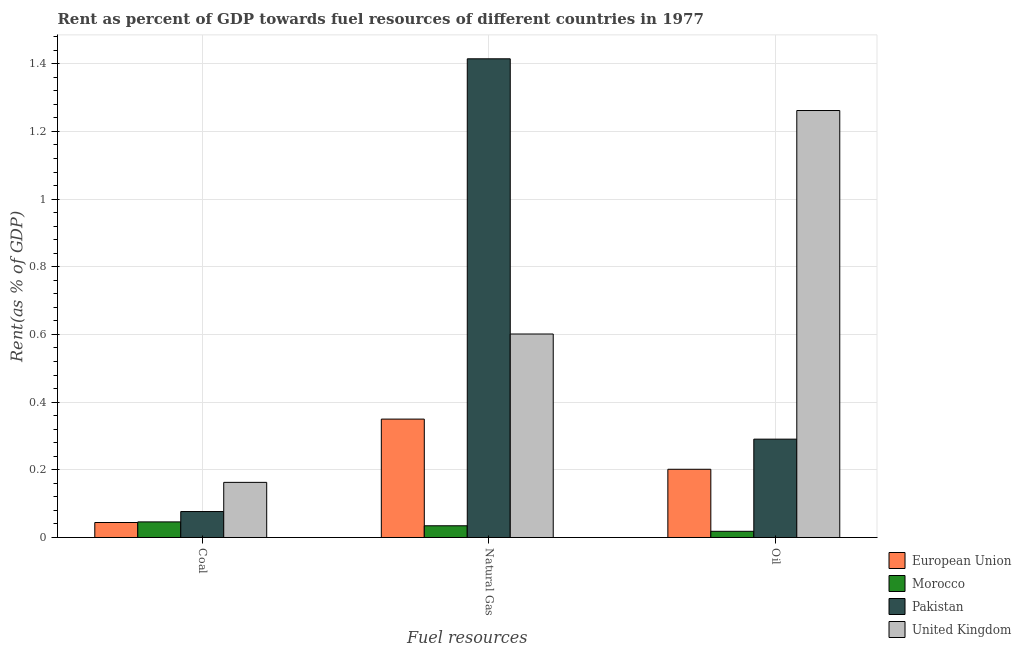How many different coloured bars are there?
Offer a terse response. 4. How many bars are there on the 3rd tick from the left?
Give a very brief answer. 4. What is the label of the 1st group of bars from the left?
Your answer should be compact. Coal. What is the rent towards coal in United Kingdom?
Give a very brief answer. 0.16. Across all countries, what is the maximum rent towards oil?
Offer a very short reply. 1.26. Across all countries, what is the minimum rent towards coal?
Your answer should be very brief. 0.04. In which country was the rent towards oil maximum?
Keep it short and to the point. United Kingdom. In which country was the rent towards coal minimum?
Provide a succinct answer. European Union. What is the total rent towards natural gas in the graph?
Provide a succinct answer. 2.4. What is the difference between the rent towards oil in Pakistan and that in United Kingdom?
Keep it short and to the point. -0.97. What is the difference between the rent towards oil in United Kingdom and the rent towards coal in Pakistan?
Your answer should be very brief. 1.18. What is the average rent towards natural gas per country?
Your answer should be compact. 0.6. What is the difference between the rent towards coal and rent towards oil in United Kingdom?
Give a very brief answer. -1.1. In how many countries, is the rent towards oil greater than 0.8400000000000001 %?
Ensure brevity in your answer.  1. What is the ratio of the rent towards oil in Morocco to that in European Union?
Make the answer very short. 0.09. Is the rent towards oil in United Kingdom less than that in Pakistan?
Your response must be concise. No. Is the difference between the rent towards natural gas in United Kingdom and Pakistan greater than the difference between the rent towards coal in United Kingdom and Pakistan?
Keep it short and to the point. No. What is the difference between the highest and the second highest rent towards oil?
Offer a very short reply. 0.97. What is the difference between the highest and the lowest rent towards oil?
Keep it short and to the point. 1.24. In how many countries, is the rent towards natural gas greater than the average rent towards natural gas taken over all countries?
Offer a very short reply. 2. What does the 2nd bar from the left in Natural Gas represents?
Your answer should be very brief. Morocco. What does the 4th bar from the right in Natural Gas represents?
Provide a succinct answer. European Union. Is it the case that in every country, the sum of the rent towards coal and rent towards natural gas is greater than the rent towards oil?
Offer a very short reply. No. How many bars are there?
Offer a terse response. 12. Are the values on the major ticks of Y-axis written in scientific E-notation?
Ensure brevity in your answer.  No. Where does the legend appear in the graph?
Your response must be concise. Bottom right. How many legend labels are there?
Make the answer very short. 4. How are the legend labels stacked?
Give a very brief answer. Vertical. What is the title of the graph?
Ensure brevity in your answer.  Rent as percent of GDP towards fuel resources of different countries in 1977. What is the label or title of the X-axis?
Offer a terse response. Fuel resources. What is the label or title of the Y-axis?
Provide a short and direct response. Rent(as % of GDP). What is the Rent(as % of GDP) of European Union in Coal?
Keep it short and to the point. 0.04. What is the Rent(as % of GDP) of Morocco in Coal?
Your response must be concise. 0.05. What is the Rent(as % of GDP) of Pakistan in Coal?
Ensure brevity in your answer.  0.08. What is the Rent(as % of GDP) of United Kingdom in Coal?
Offer a terse response. 0.16. What is the Rent(as % of GDP) of European Union in Natural Gas?
Provide a short and direct response. 0.35. What is the Rent(as % of GDP) of Morocco in Natural Gas?
Your answer should be compact. 0.03. What is the Rent(as % of GDP) of Pakistan in Natural Gas?
Ensure brevity in your answer.  1.41. What is the Rent(as % of GDP) of United Kingdom in Natural Gas?
Keep it short and to the point. 0.6. What is the Rent(as % of GDP) in European Union in Oil?
Provide a short and direct response. 0.2. What is the Rent(as % of GDP) in Morocco in Oil?
Provide a short and direct response. 0.02. What is the Rent(as % of GDP) in Pakistan in Oil?
Your response must be concise. 0.29. What is the Rent(as % of GDP) of United Kingdom in Oil?
Make the answer very short. 1.26. Across all Fuel resources, what is the maximum Rent(as % of GDP) of European Union?
Offer a terse response. 0.35. Across all Fuel resources, what is the maximum Rent(as % of GDP) in Morocco?
Keep it short and to the point. 0.05. Across all Fuel resources, what is the maximum Rent(as % of GDP) in Pakistan?
Provide a short and direct response. 1.41. Across all Fuel resources, what is the maximum Rent(as % of GDP) of United Kingdom?
Offer a terse response. 1.26. Across all Fuel resources, what is the minimum Rent(as % of GDP) of European Union?
Make the answer very short. 0.04. Across all Fuel resources, what is the minimum Rent(as % of GDP) in Morocco?
Offer a very short reply. 0.02. Across all Fuel resources, what is the minimum Rent(as % of GDP) of Pakistan?
Give a very brief answer. 0.08. Across all Fuel resources, what is the minimum Rent(as % of GDP) in United Kingdom?
Your response must be concise. 0.16. What is the total Rent(as % of GDP) in European Union in the graph?
Give a very brief answer. 0.6. What is the total Rent(as % of GDP) of Morocco in the graph?
Your response must be concise. 0.1. What is the total Rent(as % of GDP) in Pakistan in the graph?
Give a very brief answer. 1.78. What is the total Rent(as % of GDP) of United Kingdom in the graph?
Provide a short and direct response. 2.03. What is the difference between the Rent(as % of GDP) of European Union in Coal and that in Natural Gas?
Your answer should be very brief. -0.31. What is the difference between the Rent(as % of GDP) in Morocco in Coal and that in Natural Gas?
Ensure brevity in your answer.  0.01. What is the difference between the Rent(as % of GDP) in Pakistan in Coal and that in Natural Gas?
Provide a short and direct response. -1.34. What is the difference between the Rent(as % of GDP) of United Kingdom in Coal and that in Natural Gas?
Ensure brevity in your answer.  -0.44. What is the difference between the Rent(as % of GDP) of European Union in Coal and that in Oil?
Offer a very short reply. -0.16. What is the difference between the Rent(as % of GDP) in Morocco in Coal and that in Oil?
Keep it short and to the point. 0.03. What is the difference between the Rent(as % of GDP) in Pakistan in Coal and that in Oil?
Your answer should be compact. -0.21. What is the difference between the Rent(as % of GDP) of United Kingdom in Coal and that in Oil?
Offer a terse response. -1.1. What is the difference between the Rent(as % of GDP) of European Union in Natural Gas and that in Oil?
Give a very brief answer. 0.15. What is the difference between the Rent(as % of GDP) in Morocco in Natural Gas and that in Oil?
Provide a succinct answer. 0.02. What is the difference between the Rent(as % of GDP) of Pakistan in Natural Gas and that in Oil?
Provide a short and direct response. 1.12. What is the difference between the Rent(as % of GDP) of United Kingdom in Natural Gas and that in Oil?
Keep it short and to the point. -0.66. What is the difference between the Rent(as % of GDP) in European Union in Coal and the Rent(as % of GDP) in Morocco in Natural Gas?
Ensure brevity in your answer.  0.01. What is the difference between the Rent(as % of GDP) of European Union in Coal and the Rent(as % of GDP) of Pakistan in Natural Gas?
Your answer should be very brief. -1.37. What is the difference between the Rent(as % of GDP) in European Union in Coal and the Rent(as % of GDP) in United Kingdom in Natural Gas?
Offer a terse response. -0.56. What is the difference between the Rent(as % of GDP) of Morocco in Coal and the Rent(as % of GDP) of Pakistan in Natural Gas?
Make the answer very short. -1.37. What is the difference between the Rent(as % of GDP) in Morocco in Coal and the Rent(as % of GDP) in United Kingdom in Natural Gas?
Your answer should be very brief. -0.56. What is the difference between the Rent(as % of GDP) of Pakistan in Coal and the Rent(as % of GDP) of United Kingdom in Natural Gas?
Provide a succinct answer. -0.52. What is the difference between the Rent(as % of GDP) of European Union in Coal and the Rent(as % of GDP) of Morocco in Oil?
Give a very brief answer. 0.03. What is the difference between the Rent(as % of GDP) in European Union in Coal and the Rent(as % of GDP) in Pakistan in Oil?
Your answer should be very brief. -0.25. What is the difference between the Rent(as % of GDP) of European Union in Coal and the Rent(as % of GDP) of United Kingdom in Oil?
Your answer should be compact. -1.22. What is the difference between the Rent(as % of GDP) of Morocco in Coal and the Rent(as % of GDP) of Pakistan in Oil?
Your response must be concise. -0.24. What is the difference between the Rent(as % of GDP) in Morocco in Coal and the Rent(as % of GDP) in United Kingdom in Oil?
Provide a short and direct response. -1.22. What is the difference between the Rent(as % of GDP) in Pakistan in Coal and the Rent(as % of GDP) in United Kingdom in Oil?
Provide a succinct answer. -1.19. What is the difference between the Rent(as % of GDP) of European Union in Natural Gas and the Rent(as % of GDP) of Morocco in Oil?
Your response must be concise. 0.33. What is the difference between the Rent(as % of GDP) in European Union in Natural Gas and the Rent(as % of GDP) in Pakistan in Oil?
Ensure brevity in your answer.  0.06. What is the difference between the Rent(as % of GDP) in European Union in Natural Gas and the Rent(as % of GDP) in United Kingdom in Oil?
Provide a short and direct response. -0.91. What is the difference between the Rent(as % of GDP) in Morocco in Natural Gas and the Rent(as % of GDP) in Pakistan in Oil?
Give a very brief answer. -0.26. What is the difference between the Rent(as % of GDP) in Morocco in Natural Gas and the Rent(as % of GDP) in United Kingdom in Oil?
Your response must be concise. -1.23. What is the difference between the Rent(as % of GDP) in Pakistan in Natural Gas and the Rent(as % of GDP) in United Kingdom in Oil?
Your response must be concise. 0.15. What is the average Rent(as % of GDP) in European Union per Fuel resources?
Your answer should be compact. 0.2. What is the average Rent(as % of GDP) in Morocco per Fuel resources?
Make the answer very short. 0.03. What is the average Rent(as % of GDP) in Pakistan per Fuel resources?
Your response must be concise. 0.59. What is the average Rent(as % of GDP) of United Kingdom per Fuel resources?
Keep it short and to the point. 0.68. What is the difference between the Rent(as % of GDP) in European Union and Rent(as % of GDP) in Morocco in Coal?
Offer a terse response. -0. What is the difference between the Rent(as % of GDP) in European Union and Rent(as % of GDP) in Pakistan in Coal?
Keep it short and to the point. -0.03. What is the difference between the Rent(as % of GDP) in European Union and Rent(as % of GDP) in United Kingdom in Coal?
Your answer should be very brief. -0.12. What is the difference between the Rent(as % of GDP) in Morocco and Rent(as % of GDP) in Pakistan in Coal?
Provide a short and direct response. -0.03. What is the difference between the Rent(as % of GDP) of Morocco and Rent(as % of GDP) of United Kingdom in Coal?
Your answer should be very brief. -0.12. What is the difference between the Rent(as % of GDP) in Pakistan and Rent(as % of GDP) in United Kingdom in Coal?
Offer a terse response. -0.09. What is the difference between the Rent(as % of GDP) of European Union and Rent(as % of GDP) of Morocco in Natural Gas?
Your response must be concise. 0.32. What is the difference between the Rent(as % of GDP) of European Union and Rent(as % of GDP) of Pakistan in Natural Gas?
Provide a succinct answer. -1.06. What is the difference between the Rent(as % of GDP) of European Union and Rent(as % of GDP) of United Kingdom in Natural Gas?
Provide a short and direct response. -0.25. What is the difference between the Rent(as % of GDP) in Morocco and Rent(as % of GDP) in Pakistan in Natural Gas?
Offer a very short reply. -1.38. What is the difference between the Rent(as % of GDP) in Morocco and Rent(as % of GDP) in United Kingdom in Natural Gas?
Offer a very short reply. -0.57. What is the difference between the Rent(as % of GDP) of Pakistan and Rent(as % of GDP) of United Kingdom in Natural Gas?
Provide a succinct answer. 0.81. What is the difference between the Rent(as % of GDP) in European Union and Rent(as % of GDP) in Morocco in Oil?
Provide a succinct answer. 0.18. What is the difference between the Rent(as % of GDP) of European Union and Rent(as % of GDP) of Pakistan in Oil?
Provide a succinct answer. -0.09. What is the difference between the Rent(as % of GDP) of European Union and Rent(as % of GDP) of United Kingdom in Oil?
Make the answer very short. -1.06. What is the difference between the Rent(as % of GDP) of Morocco and Rent(as % of GDP) of Pakistan in Oil?
Offer a very short reply. -0.27. What is the difference between the Rent(as % of GDP) in Morocco and Rent(as % of GDP) in United Kingdom in Oil?
Offer a very short reply. -1.24. What is the difference between the Rent(as % of GDP) of Pakistan and Rent(as % of GDP) of United Kingdom in Oil?
Keep it short and to the point. -0.97. What is the ratio of the Rent(as % of GDP) in European Union in Coal to that in Natural Gas?
Ensure brevity in your answer.  0.13. What is the ratio of the Rent(as % of GDP) of Morocco in Coal to that in Natural Gas?
Keep it short and to the point. 1.33. What is the ratio of the Rent(as % of GDP) in Pakistan in Coal to that in Natural Gas?
Offer a terse response. 0.05. What is the ratio of the Rent(as % of GDP) of United Kingdom in Coal to that in Natural Gas?
Offer a terse response. 0.27. What is the ratio of the Rent(as % of GDP) in European Union in Coal to that in Oil?
Keep it short and to the point. 0.22. What is the ratio of the Rent(as % of GDP) of Morocco in Coal to that in Oil?
Offer a very short reply. 2.52. What is the ratio of the Rent(as % of GDP) in Pakistan in Coal to that in Oil?
Provide a short and direct response. 0.26. What is the ratio of the Rent(as % of GDP) in United Kingdom in Coal to that in Oil?
Give a very brief answer. 0.13. What is the ratio of the Rent(as % of GDP) in European Union in Natural Gas to that in Oil?
Offer a terse response. 1.74. What is the ratio of the Rent(as % of GDP) of Morocco in Natural Gas to that in Oil?
Your answer should be compact. 1.9. What is the ratio of the Rent(as % of GDP) in Pakistan in Natural Gas to that in Oil?
Your answer should be compact. 4.87. What is the ratio of the Rent(as % of GDP) of United Kingdom in Natural Gas to that in Oil?
Provide a succinct answer. 0.48. What is the difference between the highest and the second highest Rent(as % of GDP) of European Union?
Provide a short and direct response. 0.15. What is the difference between the highest and the second highest Rent(as % of GDP) in Morocco?
Keep it short and to the point. 0.01. What is the difference between the highest and the second highest Rent(as % of GDP) in Pakistan?
Offer a very short reply. 1.12. What is the difference between the highest and the second highest Rent(as % of GDP) in United Kingdom?
Keep it short and to the point. 0.66. What is the difference between the highest and the lowest Rent(as % of GDP) of European Union?
Provide a short and direct response. 0.31. What is the difference between the highest and the lowest Rent(as % of GDP) of Morocco?
Make the answer very short. 0.03. What is the difference between the highest and the lowest Rent(as % of GDP) of Pakistan?
Make the answer very short. 1.34. What is the difference between the highest and the lowest Rent(as % of GDP) in United Kingdom?
Your answer should be very brief. 1.1. 